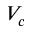Convert formula to latex. <formula><loc_0><loc_0><loc_500><loc_500>V _ { c }</formula> 